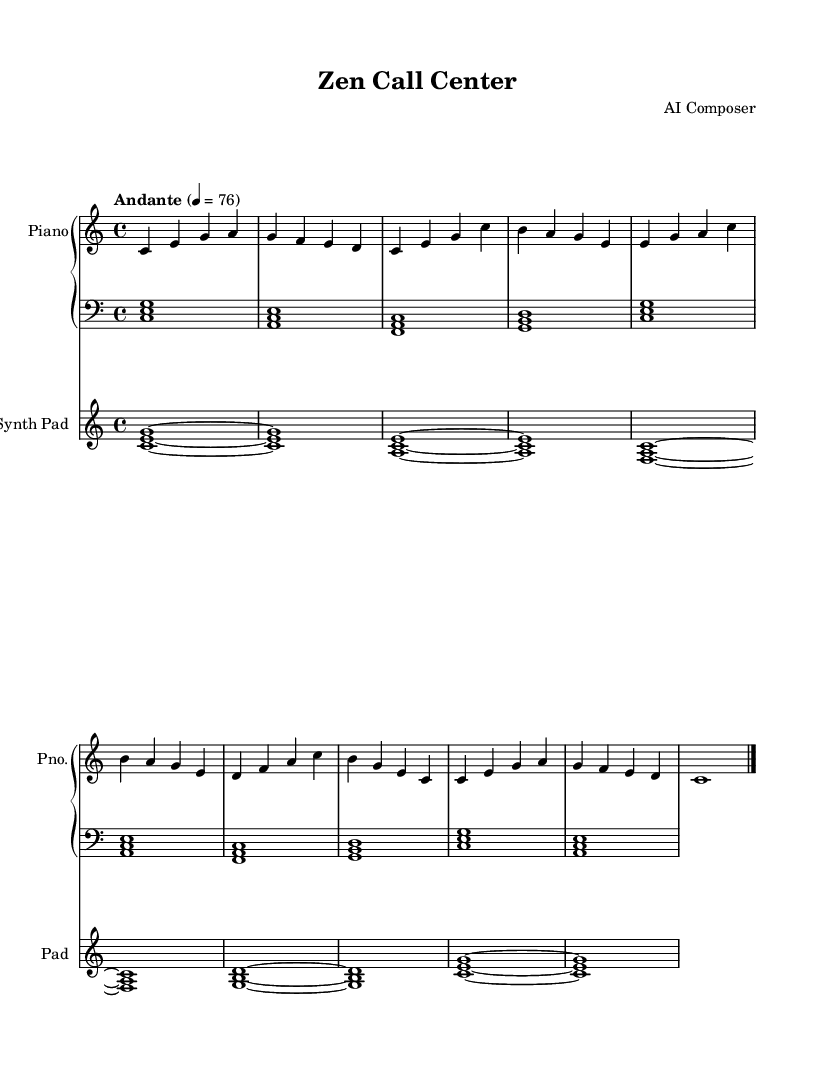What is the key signature of this music? The key signature is indicated at the beginning of the score. It shows no sharps or flats, which signifies that it is in C major.
Answer: C major What is the time signature of this piece? The time signature is found at the beginning of the score, expressed as a fraction. In this case, it is 4/4, meaning there are four beats in each measure.
Answer: 4/4 What is the tempo marking for the piece? The tempo marking is noted at the beginning and indicates the speed of the piece. The score shows "Andante" with a metronome marking of 76, meaning a moderate pace.
Answer: Andante, 76 How many measures are in the A section? The A section is comprised of four distinct phrases and can be counted by the number of measures that contain these phrases. A careful count shows that there are 8 measures in total for the A section.
Answer: 8 What is the type of instrument for the synth part? The instrument designated for the synth part is labeled at the beginning of the staff. The score clearly indicates it to be a "Synth Pad."
Answer: Synth Pad Does the music include a variation of the A section? The score shows a section labeled “A’” which signifies a variation of the original A section. This can be identified by comparing the musical material and confirming it differs from the initial A section.
Answer: Yes How many different chords are played in the piano bass part? The piano bass part shows a progression of chords, and we can determine the different chords by looking at the specified notes in the bass clef across all measures. There are four distinct chords introduced that repeat throughout.
Answer: 4 